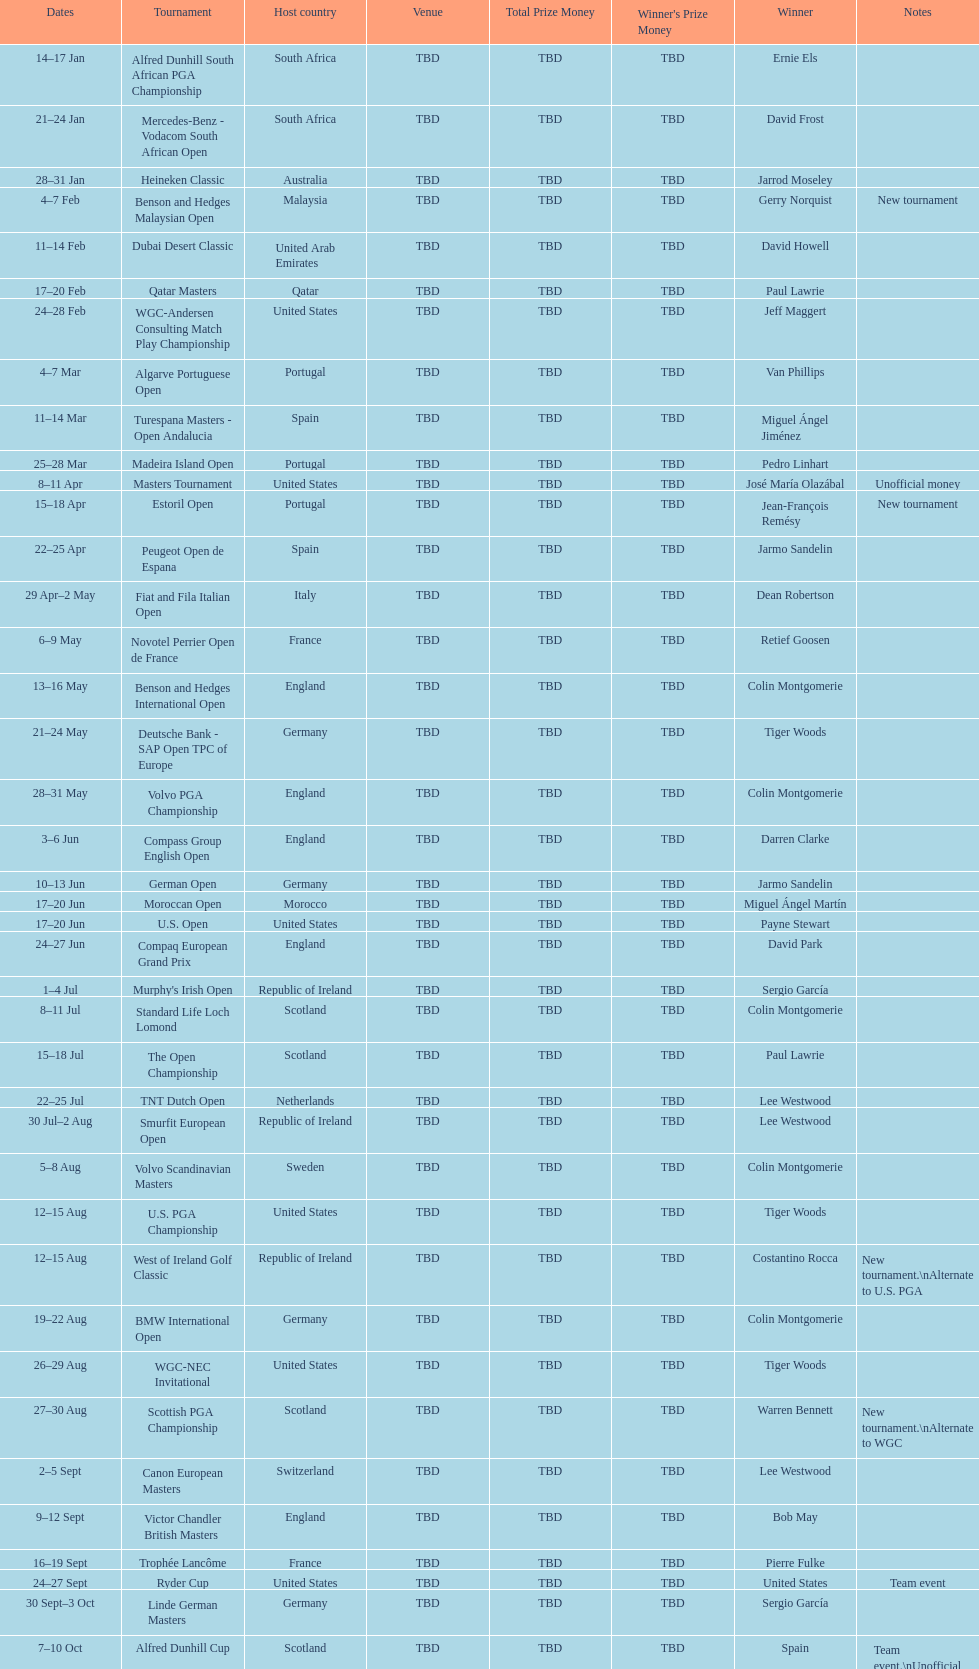Which tournament was later, volvo pga or algarve portuguese open? Volvo PGA. 